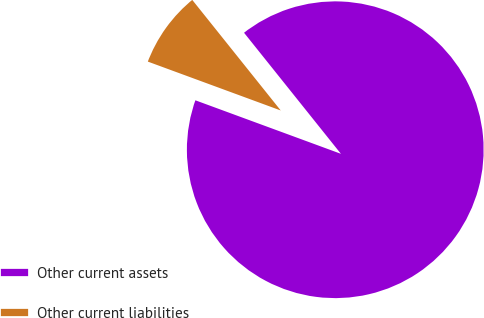Convert chart. <chart><loc_0><loc_0><loc_500><loc_500><pie_chart><fcel>Other current assets<fcel>Other current liabilities<nl><fcel>91.35%<fcel>8.65%<nl></chart> 